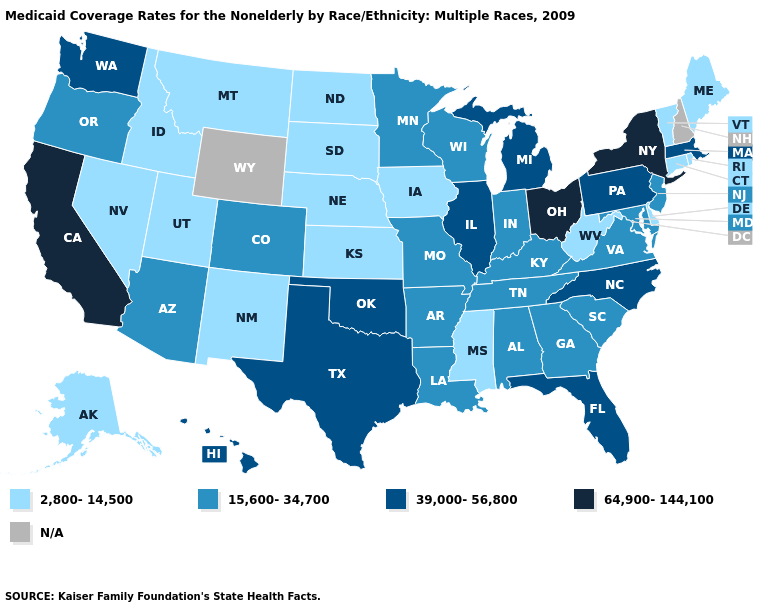Name the states that have a value in the range 2,800-14,500?
Give a very brief answer. Alaska, Connecticut, Delaware, Idaho, Iowa, Kansas, Maine, Mississippi, Montana, Nebraska, Nevada, New Mexico, North Dakota, Rhode Island, South Dakota, Utah, Vermont, West Virginia. Name the states that have a value in the range 2,800-14,500?
Answer briefly. Alaska, Connecticut, Delaware, Idaho, Iowa, Kansas, Maine, Mississippi, Montana, Nebraska, Nevada, New Mexico, North Dakota, Rhode Island, South Dakota, Utah, Vermont, West Virginia. What is the value of Massachusetts?
Write a very short answer. 39,000-56,800. What is the value of Kentucky?
Quick response, please. 15,600-34,700. Does California have the highest value in the West?
Answer briefly. Yes. What is the lowest value in the USA?
Quick response, please. 2,800-14,500. Which states have the highest value in the USA?
Give a very brief answer. California, New York, Ohio. Is the legend a continuous bar?
Give a very brief answer. No. What is the value of Massachusetts?
Give a very brief answer. 39,000-56,800. What is the lowest value in the South?
Short answer required. 2,800-14,500. Among the states that border Illinois , which have the highest value?
Answer briefly. Indiana, Kentucky, Missouri, Wisconsin. What is the value of Louisiana?
Short answer required. 15,600-34,700. Name the states that have a value in the range 15,600-34,700?
Give a very brief answer. Alabama, Arizona, Arkansas, Colorado, Georgia, Indiana, Kentucky, Louisiana, Maryland, Minnesota, Missouri, New Jersey, Oregon, South Carolina, Tennessee, Virginia, Wisconsin. How many symbols are there in the legend?
Give a very brief answer. 5. 